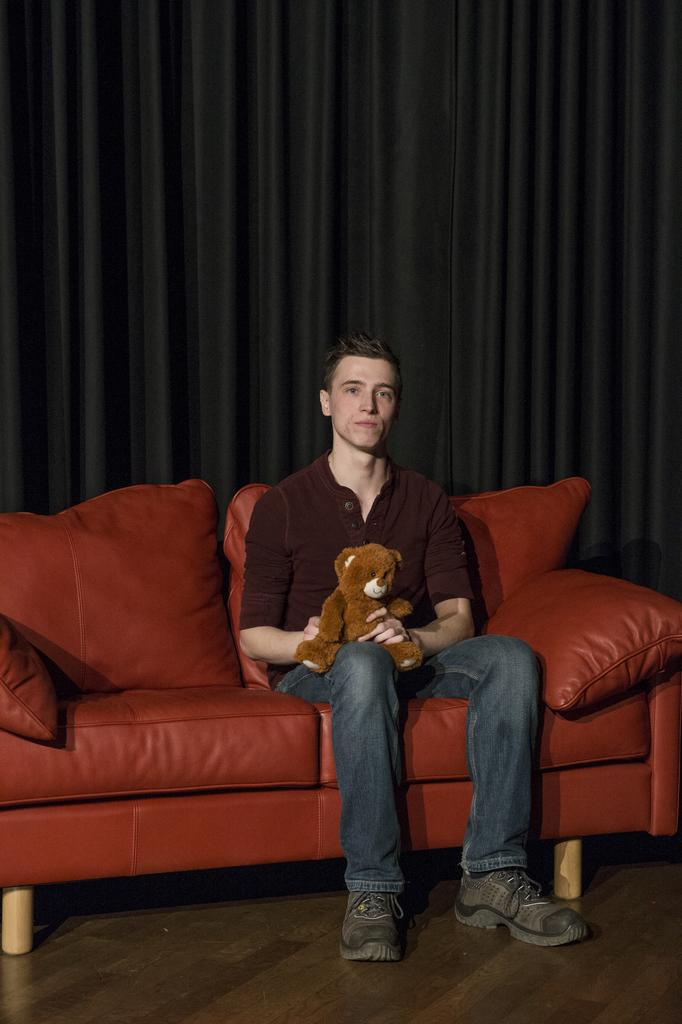What is the person in the image doing? There is a person sitting on a sofa in the image. What object is the person holding? The person is holding a teddy bear. What can be seen in the background of the image? There is a black curtain in the background. What type of substance is the person drinking in the image? There is no substance being consumed in the image; the person is holding a teddy bear. Can you tell me how many eggs are in the eggnog the person is holding? There is no eggnog present in the image, and therefore no eggs can be counted. 